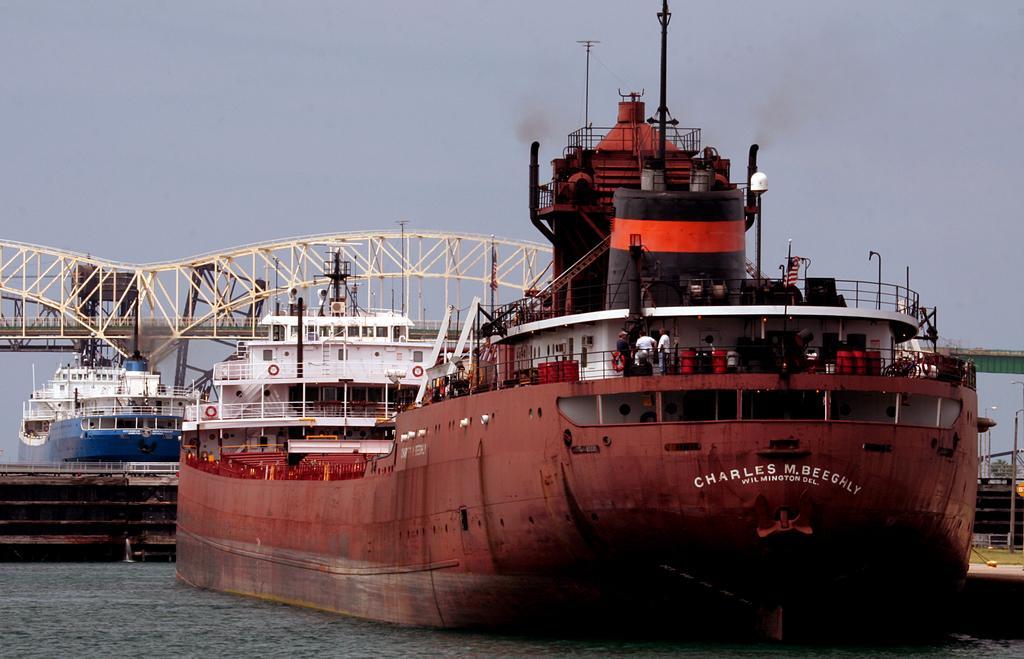How would you summarize this image in a sentence or two? In this image in the front there is a ship with some text written on it and there are persons on the ship and there are objects which are black in colour on the ship. In the background there is a blue colour ship and on the top of the ship there is a bridge. On the right side there is grass on the ground and there are poles, trees. 